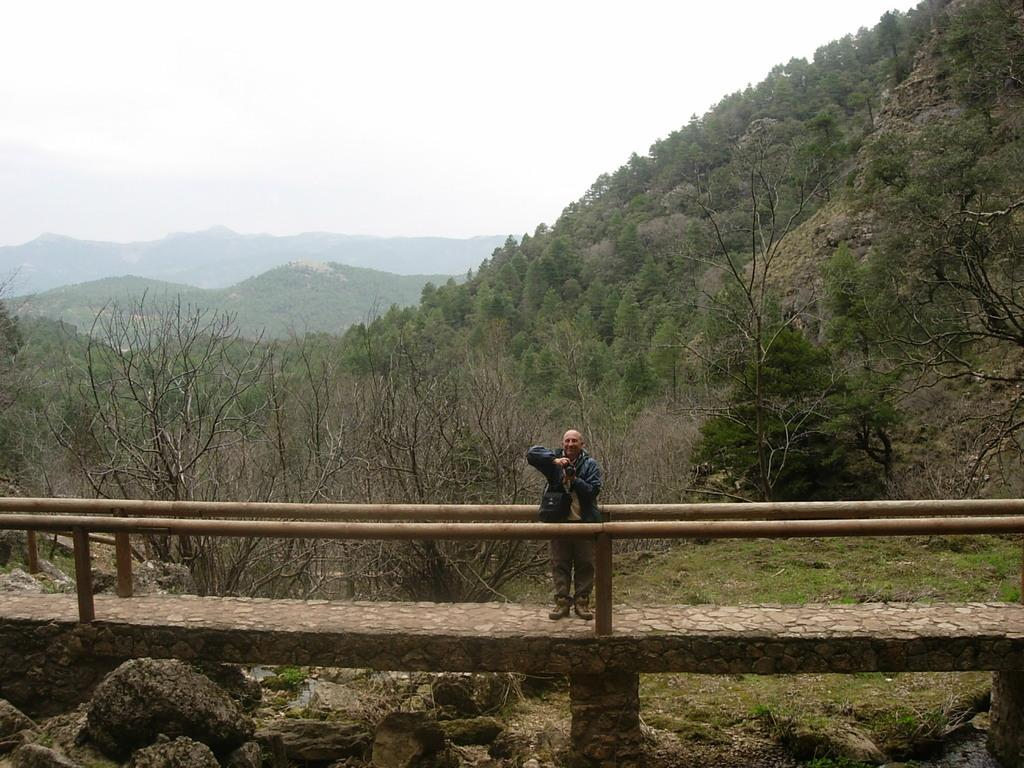What is the man doing in the image? The man is standing on a platform in the image. What type of natural environment is visible in the image? There are trees and mountains in the image. What can be seen in the background of the image? The sky is visible in the background of the image. How many apples are on the shelf in the image? There is no shelf or apple present in the image. 